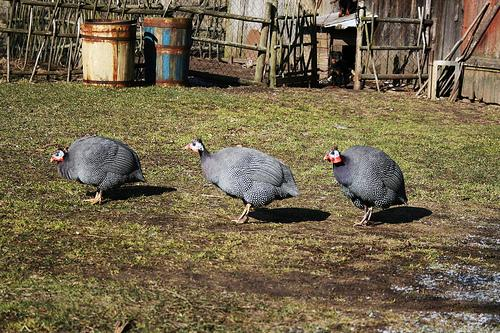What is the brown areas on the barrels? Please explain your reasoning. rust. The barrels are made out of metal. metal rusts. 